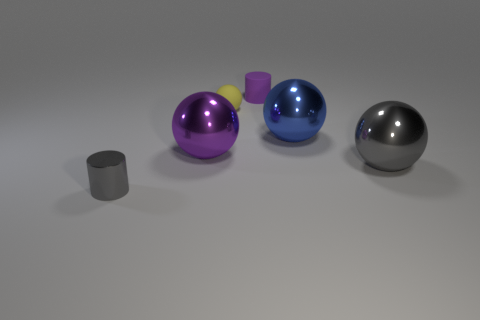Add 4 small red rubber cubes. How many objects exist? 10 Subtract all blue spheres. How many spheres are left? 3 Subtract all cylinders. How many objects are left? 4 Subtract all gray cylinders. Subtract all yellow spheres. How many cylinders are left? 1 Subtract all purple cubes. How many brown cylinders are left? 0 Subtract all big metal cylinders. Subtract all rubber objects. How many objects are left? 4 Add 1 small metallic cylinders. How many small metallic cylinders are left? 2 Add 3 blue metal things. How many blue metal things exist? 4 Subtract all purple cylinders. How many cylinders are left? 1 Subtract 0 green spheres. How many objects are left? 6 